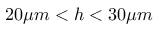Convert formula to latex. <formula><loc_0><loc_0><loc_500><loc_500>2 0 \mu m < h < 3 0 \mu m</formula> 